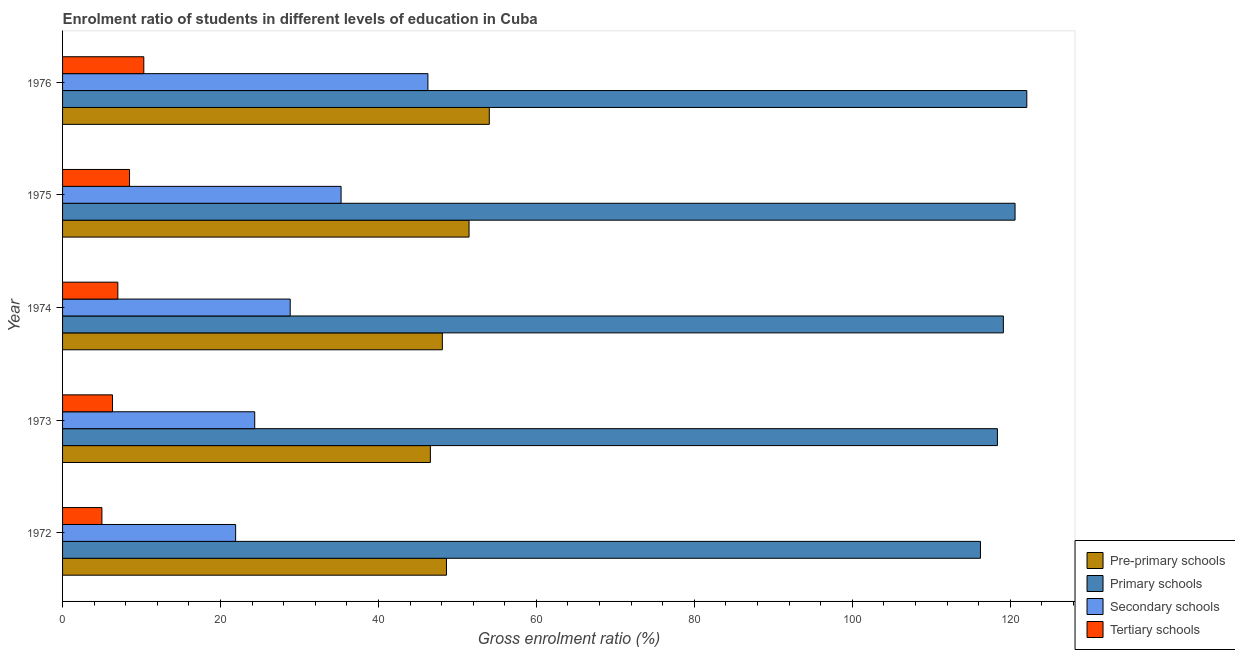Are the number of bars on each tick of the Y-axis equal?
Make the answer very short. Yes. In how many cases, is the number of bars for a given year not equal to the number of legend labels?
Offer a very short reply. 0. What is the gross enrolment ratio in pre-primary schools in 1973?
Make the answer very short. 46.57. Across all years, what is the maximum gross enrolment ratio in pre-primary schools?
Make the answer very short. 54.04. Across all years, what is the minimum gross enrolment ratio in tertiary schools?
Make the answer very short. 4.98. In which year was the gross enrolment ratio in secondary schools maximum?
Provide a short and direct response. 1976. In which year was the gross enrolment ratio in pre-primary schools minimum?
Give a very brief answer. 1973. What is the total gross enrolment ratio in pre-primary schools in the graph?
Give a very brief answer. 248.79. What is the difference between the gross enrolment ratio in tertiary schools in 1974 and that in 1975?
Provide a short and direct response. -1.48. What is the difference between the gross enrolment ratio in tertiary schools in 1974 and the gross enrolment ratio in secondary schools in 1973?
Provide a short and direct response. -17.33. What is the average gross enrolment ratio in primary schools per year?
Give a very brief answer. 119.29. In the year 1976, what is the difference between the gross enrolment ratio in secondary schools and gross enrolment ratio in pre-primary schools?
Offer a very short reply. -7.77. In how many years, is the gross enrolment ratio in pre-primary schools greater than 88 %?
Ensure brevity in your answer.  0. What is the ratio of the gross enrolment ratio in secondary schools in 1972 to that in 1973?
Offer a terse response. 0.9. Is the difference between the gross enrolment ratio in secondary schools in 1972 and 1974 greater than the difference between the gross enrolment ratio in pre-primary schools in 1972 and 1974?
Provide a succinct answer. No. What is the difference between the highest and the second highest gross enrolment ratio in pre-primary schools?
Your answer should be compact. 2.56. What is the difference between the highest and the lowest gross enrolment ratio in tertiary schools?
Keep it short and to the point. 5.31. Is the sum of the gross enrolment ratio in tertiary schools in 1973 and 1974 greater than the maximum gross enrolment ratio in secondary schools across all years?
Provide a succinct answer. No. Is it the case that in every year, the sum of the gross enrolment ratio in secondary schools and gross enrolment ratio in tertiary schools is greater than the sum of gross enrolment ratio in primary schools and gross enrolment ratio in pre-primary schools?
Offer a terse response. No. What does the 4th bar from the top in 1976 represents?
Offer a very short reply. Pre-primary schools. What does the 1st bar from the bottom in 1972 represents?
Offer a very short reply. Pre-primary schools. Are all the bars in the graph horizontal?
Provide a short and direct response. Yes. What is the difference between two consecutive major ticks on the X-axis?
Offer a terse response. 20. Where does the legend appear in the graph?
Your answer should be very brief. Bottom right. How many legend labels are there?
Make the answer very short. 4. How are the legend labels stacked?
Give a very brief answer. Vertical. What is the title of the graph?
Ensure brevity in your answer.  Enrolment ratio of students in different levels of education in Cuba. Does "Budget management" appear as one of the legend labels in the graph?
Provide a short and direct response. No. What is the label or title of the Y-axis?
Your answer should be very brief. Year. What is the Gross enrolment ratio (%) of Pre-primary schools in 1972?
Provide a succinct answer. 48.61. What is the Gross enrolment ratio (%) of Primary schools in 1972?
Give a very brief answer. 116.23. What is the Gross enrolment ratio (%) of Secondary schools in 1972?
Your answer should be very brief. 21.92. What is the Gross enrolment ratio (%) in Tertiary schools in 1972?
Offer a very short reply. 4.98. What is the Gross enrolment ratio (%) of Pre-primary schools in 1973?
Ensure brevity in your answer.  46.57. What is the Gross enrolment ratio (%) in Primary schools in 1973?
Ensure brevity in your answer.  118.38. What is the Gross enrolment ratio (%) in Secondary schools in 1973?
Ensure brevity in your answer.  24.33. What is the Gross enrolment ratio (%) in Tertiary schools in 1973?
Ensure brevity in your answer.  6.33. What is the Gross enrolment ratio (%) of Pre-primary schools in 1974?
Offer a terse response. 48.09. What is the Gross enrolment ratio (%) in Primary schools in 1974?
Ensure brevity in your answer.  119.13. What is the Gross enrolment ratio (%) of Secondary schools in 1974?
Your response must be concise. 28.82. What is the Gross enrolment ratio (%) in Tertiary schools in 1974?
Make the answer very short. 7. What is the Gross enrolment ratio (%) of Pre-primary schools in 1975?
Ensure brevity in your answer.  51.47. What is the Gross enrolment ratio (%) in Primary schools in 1975?
Your response must be concise. 120.61. What is the Gross enrolment ratio (%) in Secondary schools in 1975?
Give a very brief answer. 35.27. What is the Gross enrolment ratio (%) in Tertiary schools in 1975?
Provide a short and direct response. 8.48. What is the Gross enrolment ratio (%) in Pre-primary schools in 1976?
Provide a succinct answer. 54.04. What is the Gross enrolment ratio (%) in Primary schools in 1976?
Offer a very short reply. 122.1. What is the Gross enrolment ratio (%) in Secondary schools in 1976?
Offer a terse response. 46.26. What is the Gross enrolment ratio (%) of Tertiary schools in 1976?
Make the answer very short. 10.29. Across all years, what is the maximum Gross enrolment ratio (%) in Pre-primary schools?
Offer a terse response. 54.04. Across all years, what is the maximum Gross enrolment ratio (%) in Primary schools?
Offer a very short reply. 122.1. Across all years, what is the maximum Gross enrolment ratio (%) of Secondary schools?
Provide a succinct answer. 46.26. Across all years, what is the maximum Gross enrolment ratio (%) in Tertiary schools?
Your answer should be compact. 10.29. Across all years, what is the minimum Gross enrolment ratio (%) in Pre-primary schools?
Offer a very short reply. 46.57. Across all years, what is the minimum Gross enrolment ratio (%) in Primary schools?
Your answer should be compact. 116.23. Across all years, what is the minimum Gross enrolment ratio (%) of Secondary schools?
Your response must be concise. 21.92. Across all years, what is the minimum Gross enrolment ratio (%) in Tertiary schools?
Provide a short and direct response. 4.98. What is the total Gross enrolment ratio (%) in Pre-primary schools in the graph?
Ensure brevity in your answer.  248.79. What is the total Gross enrolment ratio (%) in Primary schools in the graph?
Your response must be concise. 596.45. What is the total Gross enrolment ratio (%) of Secondary schools in the graph?
Your response must be concise. 156.6. What is the total Gross enrolment ratio (%) in Tertiary schools in the graph?
Provide a short and direct response. 37.07. What is the difference between the Gross enrolment ratio (%) of Pre-primary schools in 1972 and that in 1973?
Give a very brief answer. 2.04. What is the difference between the Gross enrolment ratio (%) of Primary schools in 1972 and that in 1973?
Your answer should be very brief. -2.15. What is the difference between the Gross enrolment ratio (%) of Secondary schools in 1972 and that in 1973?
Your answer should be very brief. -2.42. What is the difference between the Gross enrolment ratio (%) in Tertiary schools in 1972 and that in 1973?
Make the answer very short. -1.35. What is the difference between the Gross enrolment ratio (%) of Pre-primary schools in 1972 and that in 1974?
Your answer should be very brief. 0.53. What is the difference between the Gross enrolment ratio (%) in Primary schools in 1972 and that in 1974?
Your answer should be very brief. -2.9. What is the difference between the Gross enrolment ratio (%) in Secondary schools in 1972 and that in 1974?
Your answer should be very brief. -6.91. What is the difference between the Gross enrolment ratio (%) in Tertiary schools in 1972 and that in 1974?
Offer a terse response. -2.02. What is the difference between the Gross enrolment ratio (%) in Pre-primary schools in 1972 and that in 1975?
Ensure brevity in your answer.  -2.86. What is the difference between the Gross enrolment ratio (%) of Primary schools in 1972 and that in 1975?
Make the answer very short. -4.38. What is the difference between the Gross enrolment ratio (%) of Secondary schools in 1972 and that in 1975?
Your response must be concise. -13.35. What is the difference between the Gross enrolment ratio (%) in Tertiary schools in 1972 and that in 1975?
Provide a succinct answer. -3.5. What is the difference between the Gross enrolment ratio (%) in Pre-primary schools in 1972 and that in 1976?
Give a very brief answer. -5.42. What is the difference between the Gross enrolment ratio (%) of Primary schools in 1972 and that in 1976?
Your answer should be compact. -5.87. What is the difference between the Gross enrolment ratio (%) of Secondary schools in 1972 and that in 1976?
Your answer should be very brief. -24.35. What is the difference between the Gross enrolment ratio (%) of Tertiary schools in 1972 and that in 1976?
Your answer should be very brief. -5.31. What is the difference between the Gross enrolment ratio (%) of Pre-primary schools in 1973 and that in 1974?
Provide a succinct answer. -1.52. What is the difference between the Gross enrolment ratio (%) in Primary schools in 1973 and that in 1974?
Ensure brevity in your answer.  -0.75. What is the difference between the Gross enrolment ratio (%) in Secondary schools in 1973 and that in 1974?
Your response must be concise. -4.49. What is the difference between the Gross enrolment ratio (%) in Tertiary schools in 1973 and that in 1974?
Ensure brevity in your answer.  -0.67. What is the difference between the Gross enrolment ratio (%) in Pre-primary schools in 1973 and that in 1975?
Your answer should be compact. -4.9. What is the difference between the Gross enrolment ratio (%) of Primary schools in 1973 and that in 1975?
Provide a succinct answer. -2.23. What is the difference between the Gross enrolment ratio (%) in Secondary schools in 1973 and that in 1975?
Give a very brief answer. -10.94. What is the difference between the Gross enrolment ratio (%) in Tertiary schools in 1973 and that in 1975?
Provide a short and direct response. -2.15. What is the difference between the Gross enrolment ratio (%) of Pre-primary schools in 1973 and that in 1976?
Ensure brevity in your answer.  -7.46. What is the difference between the Gross enrolment ratio (%) in Primary schools in 1973 and that in 1976?
Offer a very short reply. -3.72. What is the difference between the Gross enrolment ratio (%) of Secondary schools in 1973 and that in 1976?
Your response must be concise. -21.93. What is the difference between the Gross enrolment ratio (%) of Tertiary schools in 1973 and that in 1976?
Ensure brevity in your answer.  -3.96. What is the difference between the Gross enrolment ratio (%) in Pre-primary schools in 1974 and that in 1975?
Make the answer very short. -3.38. What is the difference between the Gross enrolment ratio (%) in Primary schools in 1974 and that in 1975?
Offer a terse response. -1.48. What is the difference between the Gross enrolment ratio (%) in Secondary schools in 1974 and that in 1975?
Offer a very short reply. -6.44. What is the difference between the Gross enrolment ratio (%) of Tertiary schools in 1974 and that in 1975?
Ensure brevity in your answer.  -1.48. What is the difference between the Gross enrolment ratio (%) of Pre-primary schools in 1974 and that in 1976?
Offer a very short reply. -5.95. What is the difference between the Gross enrolment ratio (%) in Primary schools in 1974 and that in 1976?
Provide a short and direct response. -2.97. What is the difference between the Gross enrolment ratio (%) of Secondary schools in 1974 and that in 1976?
Ensure brevity in your answer.  -17.44. What is the difference between the Gross enrolment ratio (%) of Tertiary schools in 1974 and that in 1976?
Give a very brief answer. -3.29. What is the difference between the Gross enrolment ratio (%) in Pre-primary schools in 1975 and that in 1976?
Provide a succinct answer. -2.56. What is the difference between the Gross enrolment ratio (%) of Primary schools in 1975 and that in 1976?
Your answer should be compact. -1.49. What is the difference between the Gross enrolment ratio (%) in Secondary schools in 1975 and that in 1976?
Make the answer very short. -11. What is the difference between the Gross enrolment ratio (%) of Tertiary schools in 1975 and that in 1976?
Provide a short and direct response. -1.81. What is the difference between the Gross enrolment ratio (%) in Pre-primary schools in 1972 and the Gross enrolment ratio (%) in Primary schools in 1973?
Provide a succinct answer. -69.76. What is the difference between the Gross enrolment ratio (%) of Pre-primary schools in 1972 and the Gross enrolment ratio (%) of Secondary schools in 1973?
Make the answer very short. 24.28. What is the difference between the Gross enrolment ratio (%) of Pre-primary schools in 1972 and the Gross enrolment ratio (%) of Tertiary schools in 1973?
Keep it short and to the point. 42.29. What is the difference between the Gross enrolment ratio (%) of Primary schools in 1972 and the Gross enrolment ratio (%) of Secondary schools in 1973?
Offer a very short reply. 91.9. What is the difference between the Gross enrolment ratio (%) in Primary schools in 1972 and the Gross enrolment ratio (%) in Tertiary schools in 1973?
Make the answer very short. 109.9. What is the difference between the Gross enrolment ratio (%) in Secondary schools in 1972 and the Gross enrolment ratio (%) in Tertiary schools in 1973?
Give a very brief answer. 15.59. What is the difference between the Gross enrolment ratio (%) of Pre-primary schools in 1972 and the Gross enrolment ratio (%) of Primary schools in 1974?
Keep it short and to the point. -70.52. What is the difference between the Gross enrolment ratio (%) of Pre-primary schools in 1972 and the Gross enrolment ratio (%) of Secondary schools in 1974?
Make the answer very short. 19.79. What is the difference between the Gross enrolment ratio (%) in Pre-primary schools in 1972 and the Gross enrolment ratio (%) in Tertiary schools in 1974?
Offer a very short reply. 41.61. What is the difference between the Gross enrolment ratio (%) of Primary schools in 1972 and the Gross enrolment ratio (%) of Secondary schools in 1974?
Make the answer very short. 87.41. What is the difference between the Gross enrolment ratio (%) in Primary schools in 1972 and the Gross enrolment ratio (%) in Tertiary schools in 1974?
Your response must be concise. 109.23. What is the difference between the Gross enrolment ratio (%) in Secondary schools in 1972 and the Gross enrolment ratio (%) in Tertiary schools in 1974?
Make the answer very short. 14.92. What is the difference between the Gross enrolment ratio (%) in Pre-primary schools in 1972 and the Gross enrolment ratio (%) in Primary schools in 1975?
Provide a short and direct response. -72. What is the difference between the Gross enrolment ratio (%) in Pre-primary schools in 1972 and the Gross enrolment ratio (%) in Secondary schools in 1975?
Give a very brief answer. 13.35. What is the difference between the Gross enrolment ratio (%) of Pre-primary schools in 1972 and the Gross enrolment ratio (%) of Tertiary schools in 1975?
Your answer should be compact. 40.13. What is the difference between the Gross enrolment ratio (%) in Primary schools in 1972 and the Gross enrolment ratio (%) in Secondary schools in 1975?
Ensure brevity in your answer.  80.96. What is the difference between the Gross enrolment ratio (%) of Primary schools in 1972 and the Gross enrolment ratio (%) of Tertiary schools in 1975?
Your answer should be compact. 107.75. What is the difference between the Gross enrolment ratio (%) of Secondary schools in 1972 and the Gross enrolment ratio (%) of Tertiary schools in 1975?
Offer a terse response. 13.44. What is the difference between the Gross enrolment ratio (%) of Pre-primary schools in 1972 and the Gross enrolment ratio (%) of Primary schools in 1976?
Keep it short and to the point. -73.48. What is the difference between the Gross enrolment ratio (%) in Pre-primary schools in 1972 and the Gross enrolment ratio (%) in Secondary schools in 1976?
Offer a terse response. 2.35. What is the difference between the Gross enrolment ratio (%) in Pre-primary schools in 1972 and the Gross enrolment ratio (%) in Tertiary schools in 1976?
Make the answer very short. 38.33. What is the difference between the Gross enrolment ratio (%) of Primary schools in 1972 and the Gross enrolment ratio (%) of Secondary schools in 1976?
Offer a very short reply. 69.97. What is the difference between the Gross enrolment ratio (%) of Primary schools in 1972 and the Gross enrolment ratio (%) of Tertiary schools in 1976?
Make the answer very short. 105.94. What is the difference between the Gross enrolment ratio (%) of Secondary schools in 1972 and the Gross enrolment ratio (%) of Tertiary schools in 1976?
Make the answer very short. 11.63. What is the difference between the Gross enrolment ratio (%) in Pre-primary schools in 1973 and the Gross enrolment ratio (%) in Primary schools in 1974?
Give a very brief answer. -72.56. What is the difference between the Gross enrolment ratio (%) of Pre-primary schools in 1973 and the Gross enrolment ratio (%) of Secondary schools in 1974?
Ensure brevity in your answer.  17.75. What is the difference between the Gross enrolment ratio (%) of Pre-primary schools in 1973 and the Gross enrolment ratio (%) of Tertiary schools in 1974?
Ensure brevity in your answer.  39.57. What is the difference between the Gross enrolment ratio (%) of Primary schools in 1973 and the Gross enrolment ratio (%) of Secondary schools in 1974?
Your response must be concise. 89.55. What is the difference between the Gross enrolment ratio (%) of Primary schools in 1973 and the Gross enrolment ratio (%) of Tertiary schools in 1974?
Your response must be concise. 111.38. What is the difference between the Gross enrolment ratio (%) of Secondary schools in 1973 and the Gross enrolment ratio (%) of Tertiary schools in 1974?
Ensure brevity in your answer.  17.33. What is the difference between the Gross enrolment ratio (%) of Pre-primary schools in 1973 and the Gross enrolment ratio (%) of Primary schools in 1975?
Give a very brief answer. -74.04. What is the difference between the Gross enrolment ratio (%) in Pre-primary schools in 1973 and the Gross enrolment ratio (%) in Secondary schools in 1975?
Your answer should be compact. 11.31. What is the difference between the Gross enrolment ratio (%) in Pre-primary schools in 1973 and the Gross enrolment ratio (%) in Tertiary schools in 1975?
Offer a very short reply. 38.09. What is the difference between the Gross enrolment ratio (%) in Primary schools in 1973 and the Gross enrolment ratio (%) in Secondary schools in 1975?
Your answer should be very brief. 83.11. What is the difference between the Gross enrolment ratio (%) of Primary schools in 1973 and the Gross enrolment ratio (%) of Tertiary schools in 1975?
Provide a short and direct response. 109.9. What is the difference between the Gross enrolment ratio (%) of Secondary schools in 1973 and the Gross enrolment ratio (%) of Tertiary schools in 1975?
Keep it short and to the point. 15.85. What is the difference between the Gross enrolment ratio (%) in Pre-primary schools in 1973 and the Gross enrolment ratio (%) in Primary schools in 1976?
Provide a short and direct response. -75.53. What is the difference between the Gross enrolment ratio (%) in Pre-primary schools in 1973 and the Gross enrolment ratio (%) in Secondary schools in 1976?
Offer a terse response. 0.31. What is the difference between the Gross enrolment ratio (%) of Pre-primary schools in 1973 and the Gross enrolment ratio (%) of Tertiary schools in 1976?
Give a very brief answer. 36.29. What is the difference between the Gross enrolment ratio (%) in Primary schools in 1973 and the Gross enrolment ratio (%) in Secondary schools in 1976?
Your response must be concise. 72.11. What is the difference between the Gross enrolment ratio (%) of Primary schools in 1973 and the Gross enrolment ratio (%) of Tertiary schools in 1976?
Give a very brief answer. 108.09. What is the difference between the Gross enrolment ratio (%) of Secondary schools in 1973 and the Gross enrolment ratio (%) of Tertiary schools in 1976?
Offer a terse response. 14.05. What is the difference between the Gross enrolment ratio (%) of Pre-primary schools in 1974 and the Gross enrolment ratio (%) of Primary schools in 1975?
Offer a very short reply. -72.52. What is the difference between the Gross enrolment ratio (%) of Pre-primary schools in 1974 and the Gross enrolment ratio (%) of Secondary schools in 1975?
Provide a short and direct response. 12.82. What is the difference between the Gross enrolment ratio (%) of Pre-primary schools in 1974 and the Gross enrolment ratio (%) of Tertiary schools in 1975?
Offer a very short reply. 39.61. What is the difference between the Gross enrolment ratio (%) of Primary schools in 1974 and the Gross enrolment ratio (%) of Secondary schools in 1975?
Provide a succinct answer. 83.86. What is the difference between the Gross enrolment ratio (%) in Primary schools in 1974 and the Gross enrolment ratio (%) in Tertiary schools in 1975?
Provide a succinct answer. 110.65. What is the difference between the Gross enrolment ratio (%) in Secondary schools in 1974 and the Gross enrolment ratio (%) in Tertiary schools in 1975?
Offer a terse response. 20.34. What is the difference between the Gross enrolment ratio (%) of Pre-primary schools in 1974 and the Gross enrolment ratio (%) of Primary schools in 1976?
Your response must be concise. -74.01. What is the difference between the Gross enrolment ratio (%) in Pre-primary schools in 1974 and the Gross enrolment ratio (%) in Secondary schools in 1976?
Ensure brevity in your answer.  1.83. What is the difference between the Gross enrolment ratio (%) in Pre-primary schools in 1974 and the Gross enrolment ratio (%) in Tertiary schools in 1976?
Offer a terse response. 37.8. What is the difference between the Gross enrolment ratio (%) of Primary schools in 1974 and the Gross enrolment ratio (%) of Secondary schools in 1976?
Your response must be concise. 72.87. What is the difference between the Gross enrolment ratio (%) of Primary schools in 1974 and the Gross enrolment ratio (%) of Tertiary schools in 1976?
Offer a very short reply. 108.84. What is the difference between the Gross enrolment ratio (%) in Secondary schools in 1974 and the Gross enrolment ratio (%) in Tertiary schools in 1976?
Offer a terse response. 18.54. What is the difference between the Gross enrolment ratio (%) in Pre-primary schools in 1975 and the Gross enrolment ratio (%) in Primary schools in 1976?
Make the answer very short. -70.63. What is the difference between the Gross enrolment ratio (%) of Pre-primary schools in 1975 and the Gross enrolment ratio (%) of Secondary schools in 1976?
Your answer should be very brief. 5.21. What is the difference between the Gross enrolment ratio (%) in Pre-primary schools in 1975 and the Gross enrolment ratio (%) in Tertiary schools in 1976?
Your response must be concise. 41.19. What is the difference between the Gross enrolment ratio (%) of Primary schools in 1975 and the Gross enrolment ratio (%) of Secondary schools in 1976?
Give a very brief answer. 74.35. What is the difference between the Gross enrolment ratio (%) in Primary schools in 1975 and the Gross enrolment ratio (%) in Tertiary schools in 1976?
Provide a succinct answer. 110.32. What is the difference between the Gross enrolment ratio (%) of Secondary schools in 1975 and the Gross enrolment ratio (%) of Tertiary schools in 1976?
Give a very brief answer. 24.98. What is the average Gross enrolment ratio (%) of Pre-primary schools per year?
Provide a short and direct response. 49.76. What is the average Gross enrolment ratio (%) of Primary schools per year?
Offer a very short reply. 119.29. What is the average Gross enrolment ratio (%) in Secondary schools per year?
Ensure brevity in your answer.  31.32. What is the average Gross enrolment ratio (%) of Tertiary schools per year?
Your answer should be compact. 7.41. In the year 1972, what is the difference between the Gross enrolment ratio (%) of Pre-primary schools and Gross enrolment ratio (%) of Primary schools?
Provide a short and direct response. -67.62. In the year 1972, what is the difference between the Gross enrolment ratio (%) in Pre-primary schools and Gross enrolment ratio (%) in Secondary schools?
Keep it short and to the point. 26.7. In the year 1972, what is the difference between the Gross enrolment ratio (%) of Pre-primary schools and Gross enrolment ratio (%) of Tertiary schools?
Your answer should be compact. 43.63. In the year 1972, what is the difference between the Gross enrolment ratio (%) of Primary schools and Gross enrolment ratio (%) of Secondary schools?
Your response must be concise. 94.31. In the year 1972, what is the difference between the Gross enrolment ratio (%) in Primary schools and Gross enrolment ratio (%) in Tertiary schools?
Provide a short and direct response. 111.25. In the year 1972, what is the difference between the Gross enrolment ratio (%) of Secondary schools and Gross enrolment ratio (%) of Tertiary schools?
Provide a short and direct response. 16.94. In the year 1973, what is the difference between the Gross enrolment ratio (%) of Pre-primary schools and Gross enrolment ratio (%) of Primary schools?
Offer a very short reply. -71.8. In the year 1973, what is the difference between the Gross enrolment ratio (%) in Pre-primary schools and Gross enrolment ratio (%) in Secondary schools?
Provide a short and direct response. 22.24. In the year 1973, what is the difference between the Gross enrolment ratio (%) of Pre-primary schools and Gross enrolment ratio (%) of Tertiary schools?
Your response must be concise. 40.25. In the year 1973, what is the difference between the Gross enrolment ratio (%) in Primary schools and Gross enrolment ratio (%) in Secondary schools?
Your answer should be very brief. 94.05. In the year 1973, what is the difference between the Gross enrolment ratio (%) in Primary schools and Gross enrolment ratio (%) in Tertiary schools?
Give a very brief answer. 112.05. In the year 1973, what is the difference between the Gross enrolment ratio (%) in Secondary schools and Gross enrolment ratio (%) in Tertiary schools?
Your response must be concise. 18.01. In the year 1974, what is the difference between the Gross enrolment ratio (%) in Pre-primary schools and Gross enrolment ratio (%) in Primary schools?
Your response must be concise. -71.04. In the year 1974, what is the difference between the Gross enrolment ratio (%) of Pre-primary schools and Gross enrolment ratio (%) of Secondary schools?
Provide a succinct answer. 19.27. In the year 1974, what is the difference between the Gross enrolment ratio (%) in Pre-primary schools and Gross enrolment ratio (%) in Tertiary schools?
Provide a short and direct response. 41.09. In the year 1974, what is the difference between the Gross enrolment ratio (%) of Primary schools and Gross enrolment ratio (%) of Secondary schools?
Provide a succinct answer. 90.31. In the year 1974, what is the difference between the Gross enrolment ratio (%) in Primary schools and Gross enrolment ratio (%) in Tertiary schools?
Your response must be concise. 112.13. In the year 1974, what is the difference between the Gross enrolment ratio (%) of Secondary schools and Gross enrolment ratio (%) of Tertiary schools?
Give a very brief answer. 21.82. In the year 1975, what is the difference between the Gross enrolment ratio (%) in Pre-primary schools and Gross enrolment ratio (%) in Primary schools?
Provide a succinct answer. -69.14. In the year 1975, what is the difference between the Gross enrolment ratio (%) of Pre-primary schools and Gross enrolment ratio (%) of Secondary schools?
Provide a succinct answer. 16.2. In the year 1975, what is the difference between the Gross enrolment ratio (%) in Pre-primary schools and Gross enrolment ratio (%) in Tertiary schools?
Your answer should be compact. 42.99. In the year 1975, what is the difference between the Gross enrolment ratio (%) of Primary schools and Gross enrolment ratio (%) of Secondary schools?
Give a very brief answer. 85.34. In the year 1975, what is the difference between the Gross enrolment ratio (%) of Primary schools and Gross enrolment ratio (%) of Tertiary schools?
Provide a short and direct response. 112.13. In the year 1975, what is the difference between the Gross enrolment ratio (%) in Secondary schools and Gross enrolment ratio (%) in Tertiary schools?
Your answer should be very brief. 26.79. In the year 1976, what is the difference between the Gross enrolment ratio (%) in Pre-primary schools and Gross enrolment ratio (%) in Primary schools?
Your answer should be very brief. -68.06. In the year 1976, what is the difference between the Gross enrolment ratio (%) of Pre-primary schools and Gross enrolment ratio (%) of Secondary schools?
Provide a succinct answer. 7.77. In the year 1976, what is the difference between the Gross enrolment ratio (%) of Pre-primary schools and Gross enrolment ratio (%) of Tertiary schools?
Keep it short and to the point. 43.75. In the year 1976, what is the difference between the Gross enrolment ratio (%) of Primary schools and Gross enrolment ratio (%) of Secondary schools?
Give a very brief answer. 75.84. In the year 1976, what is the difference between the Gross enrolment ratio (%) of Primary schools and Gross enrolment ratio (%) of Tertiary schools?
Your answer should be very brief. 111.81. In the year 1976, what is the difference between the Gross enrolment ratio (%) in Secondary schools and Gross enrolment ratio (%) in Tertiary schools?
Give a very brief answer. 35.98. What is the ratio of the Gross enrolment ratio (%) of Pre-primary schools in 1972 to that in 1973?
Keep it short and to the point. 1.04. What is the ratio of the Gross enrolment ratio (%) of Primary schools in 1972 to that in 1973?
Provide a short and direct response. 0.98. What is the ratio of the Gross enrolment ratio (%) in Secondary schools in 1972 to that in 1973?
Offer a terse response. 0.9. What is the ratio of the Gross enrolment ratio (%) of Tertiary schools in 1972 to that in 1973?
Your answer should be compact. 0.79. What is the ratio of the Gross enrolment ratio (%) in Pre-primary schools in 1972 to that in 1974?
Provide a succinct answer. 1.01. What is the ratio of the Gross enrolment ratio (%) in Primary schools in 1972 to that in 1974?
Your response must be concise. 0.98. What is the ratio of the Gross enrolment ratio (%) in Secondary schools in 1972 to that in 1974?
Ensure brevity in your answer.  0.76. What is the ratio of the Gross enrolment ratio (%) of Tertiary schools in 1972 to that in 1974?
Provide a succinct answer. 0.71. What is the ratio of the Gross enrolment ratio (%) in Pre-primary schools in 1972 to that in 1975?
Offer a terse response. 0.94. What is the ratio of the Gross enrolment ratio (%) of Primary schools in 1972 to that in 1975?
Keep it short and to the point. 0.96. What is the ratio of the Gross enrolment ratio (%) in Secondary schools in 1972 to that in 1975?
Offer a very short reply. 0.62. What is the ratio of the Gross enrolment ratio (%) of Tertiary schools in 1972 to that in 1975?
Offer a terse response. 0.59. What is the ratio of the Gross enrolment ratio (%) in Pre-primary schools in 1972 to that in 1976?
Offer a very short reply. 0.9. What is the ratio of the Gross enrolment ratio (%) of Primary schools in 1972 to that in 1976?
Offer a very short reply. 0.95. What is the ratio of the Gross enrolment ratio (%) of Secondary schools in 1972 to that in 1976?
Provide a short and direct response. 0.47. What is the ratio of the Gross enrolment ratio (%) in Tertiary schools in 1972 to that in 1976?
Ensure brevity in your answer.  0.48. What is the ratio of the Gross enrolment ratio (%) in Pre-primary schools in 1973 to that in 1974?
Your answer should be compact. 0.97. What is the ratio of the Gross enrolment ratio (%) in Secondary schools in 1973 to that in 1974?
Your answer should be very brief. 0.84. What is the ratio of the Gross enrolment ratio (%) of Tertiary schools in 1973 to that in 1974?
Keep it short and to the point. 0.9. What is the ratio of the Gross enrolment ratio (%) of Pre-primary schools in 1973 to that in 1975?
Provide a succinct answer. 0.9. What is the ratio of the Gross enrolment ratio (%) in Primary schools in 1973 to that in 1975?
Give a very brief answer. 0.98. What is the ratio of the Gross enrolment ratio (%) in Secondary schools in 1973 to that in 1975?
Provide a succinct answer. 0.69. What is the ratio of the Gross enrolment ratio (%) of Tertiary schools in 1973 to that in 1975?
Your answer should be very brief. 0.75. What is the ratio of the Gross enrolment ratio (%) in Pre-primary schools in 1973 to that in 1976?
Keep it short and to the point. 0.86. What is the ratio of the Gross enrolment ratio (%) in Primary schools in 1973 to that in 1976?
Keep it short and to the point. 0.97. What is the ratio of the Gross enrolment ratio (%) in Secondary schools in 1973 to that in 1976?
Your response must be concise. 0.53. What is the ratio of the Gross enrolment ratio (%) in Tertiary schools in 1973 to that in 1976?
Provide a succinct answer. 0.61. What is the ratio of the Gross enrolment ratio (%) in Pre-primary schools in 1974 to that in 1975?
Your response must be concise. 0.93. What is the ratio of the Gross enrolment ratio (%) in Secondary schools in 1974 to that in 1975?
Make the answer very short. 0.82. What is the ratio of the Gross enrolment ratio (%) of Tertiary schools in 1974 to that in 1975?
Your response must be concise. 0.83. What is the ratio of the Gross enrolment ratio (%) in Pre-primary schools in 1974 to that in 1976?
Ensure brevity in your answer.  0.89. What is the ratio of the Gross enrolment ratio (%) in Primary schools in 1974 to that in 1976?
Keep it short and to the point. 0.98. What is the ratio of the Gross enrolment ratio (%) in Secondary schools in 1974 to that in 1976?
Make the answer very short. 0.62. What is the ratio of the Gross enrolment ratio (%) in Tertiary schools in 1974 to that in 1976?
Make the answer very short. 0.68. What is the ratio of the Gross enrolment ratio (%) of Pre-primary schools in 1975 to that in 1976?
Ensure brevity in your answer.  0.95. What is the ratio of the Gross enrolment ratio (%) in Secondary schools in 1975 to that in 1976?
Offer a terse response. 0.76. What is the ratio of the Gross enrolment ratio (%) of Tertiary schools in 1975 to that in 1976?
Offer a very short reply. 0.82. What is the difference between the highest and the second highest Gross enrolment ratio (%) in Pre-primary schools?
Provide a succinct answer. 2.56. What is the difference between the highest and the second highest Gross enrolment ratio (%) in Primary schools?
Keep it short and to the point. 1.49. What is the difference between the highest and the second highest Gross enrolment ratio (%) in Secondary schools?
Your response must be concise. 11. What is the difference between the highest and the second highest Gross enrolment ratio (%) in Tertiary schools?
Offer a terse response. 1.81. What is the difference between the highest and the lowest Gross enrolment ratio (%) of Pre-primary schools?
Your answer should be very brief. 7.46. What is the difference between the highest and the lowest Gross enrolment ratio (%) in Primary schools?
Offer a very short reply. 5.87. What is the difference between the highest and the lowest Gross enrolment ratio (%) of Secondary schools?
Your answer should be compact. 24.35. What is the difference between the highest and the lowest Gross enrolment ratio (%) of Tertiary schools?
Ensure brevity in your answer.  5.31. 